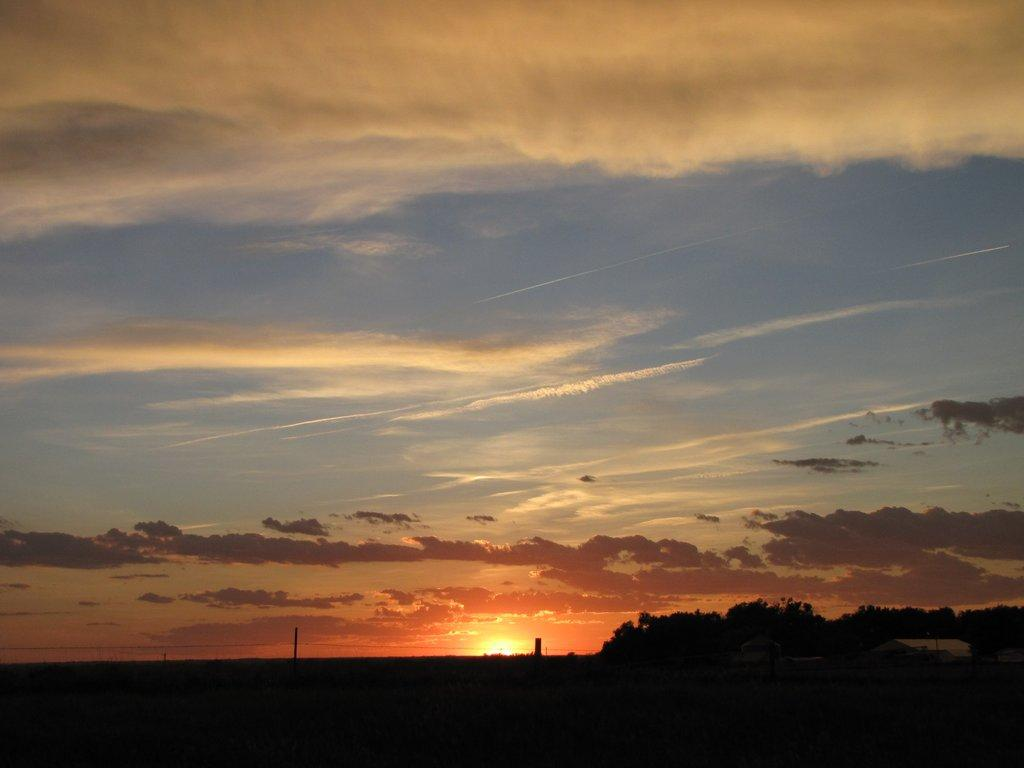What type of vegetation can be seen at the bottom of the image? There are trees visible at the bottom of the image. What time of day is depicted in the image? The image depicts a sunset. What is visible at the top of the image? The sky is visible at the top of the image. Can you see a bear performing on a stage in the image? There is no bear or stage present in the image. What type of wheel is visible in the image? There is no wheel present in the image. 